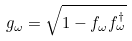Convert formula to latex. <formula><loc_0><loc_0><loc_500><loc_500>g _ { \omega } = { \sqrt { 1 - f _ { \omega } f _ { \omega } ^ { \dagger } } }</formula> 